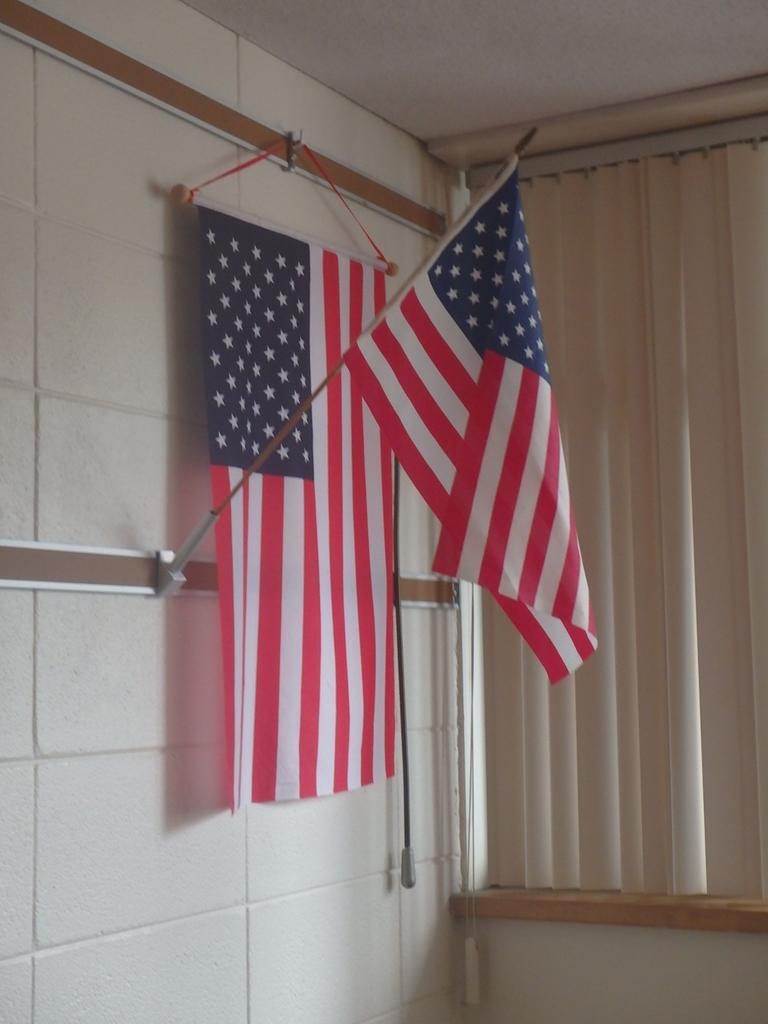Please provide a concise description of this image. In this picture we can see flags, wall and some objects and in the background we can see a roof, curtain. 